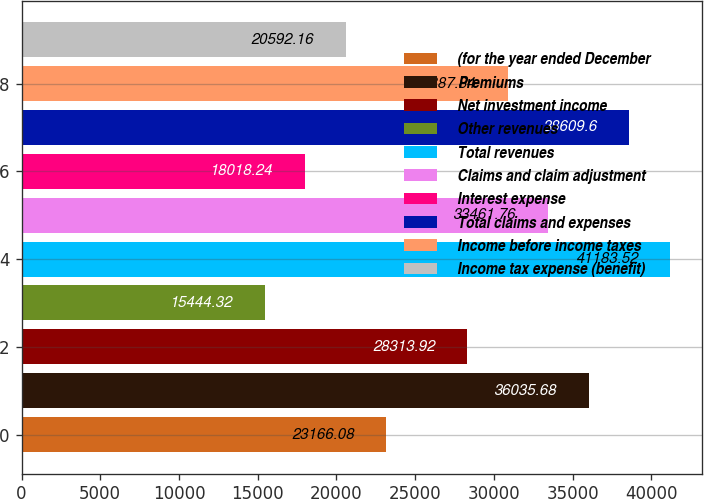Convert chart. <chart><loc_0><loc_0><loc_500><loc_500><bar_chart><fcel>(for the year ended December<fcel>Premiums<fcel>Net investment income<fcel>Other revenues<fcel>Total revenues<fcel>Claims and claim adjustment<fcel>Interest expense<fcel>Total claims and expenses<fcel>Income before income taxes<fcel>Income tax expense (benefit)<nl><fcel>23166.1<fcel>36035.7<fcel>28313.9<fcel>15444.3<fcel>41183.5<fcel>33461.8<fcel>18018.2<fcel>38609.6<fcel>30887.8<fcel>20592.2<nl></chart> 